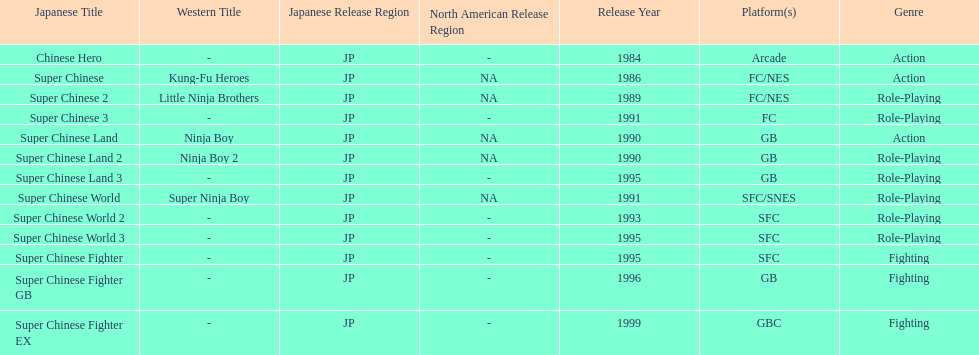Number of super chinese world games released 3. 